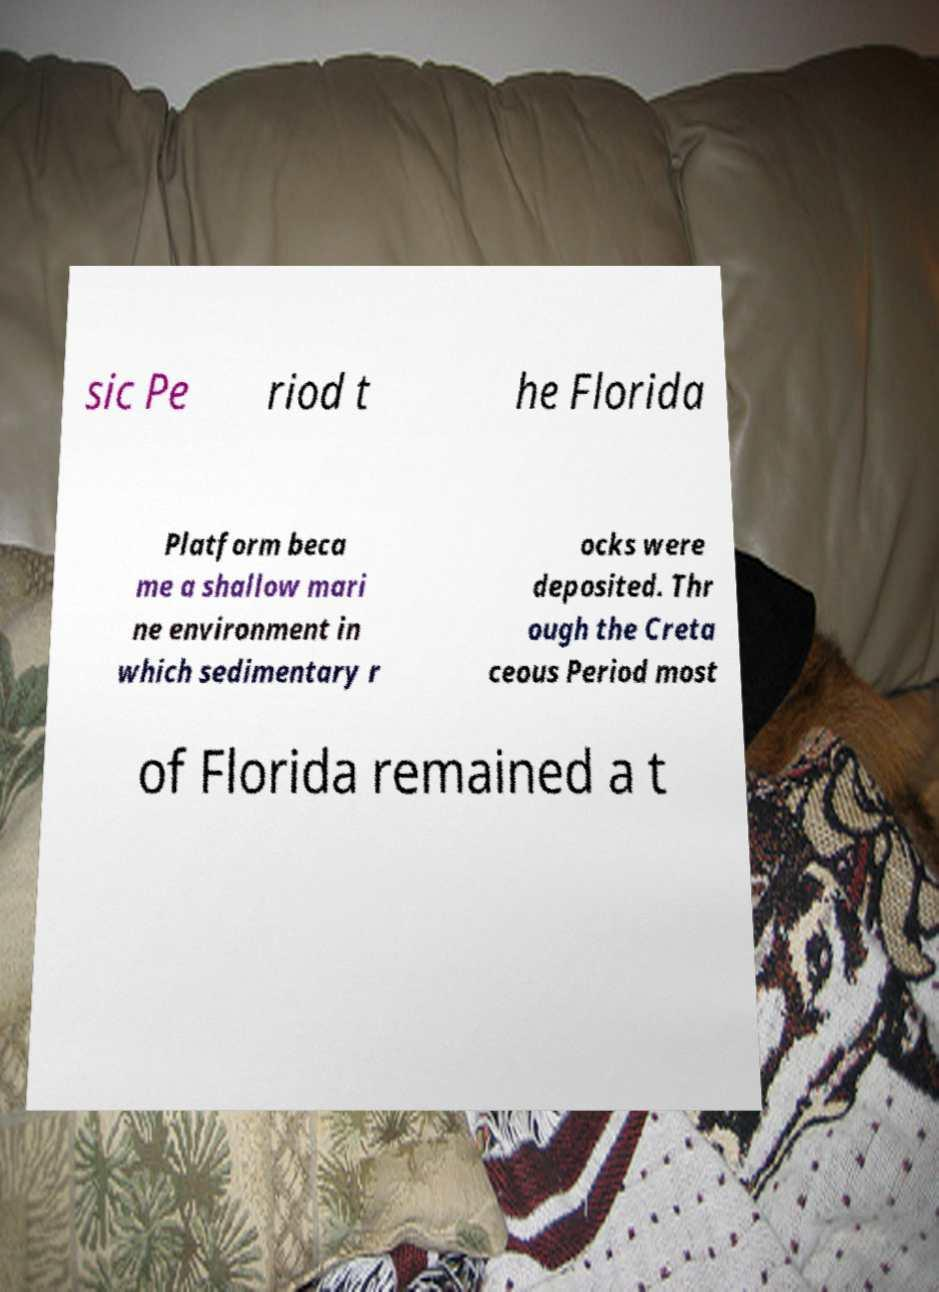What messages or text are displayed in this image? I need them in a readable, typed format. sic Pe riod t he Florida Platform beca me a shallow mari ne environment in which sedimentary r ocks were deposited. Thr ough the Creta ceous Period most of Florida remained a t 